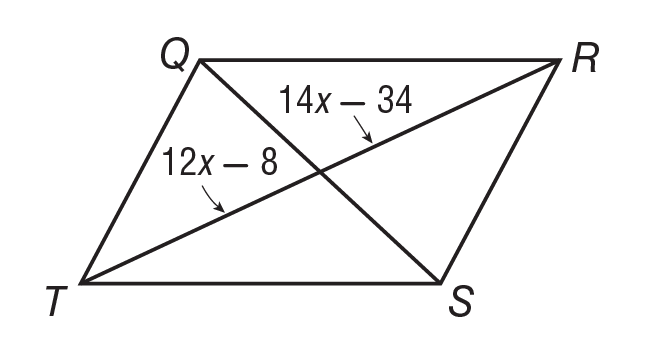Answer the mathemtical geometry problem and directly provide the correct option letter.
Question: If Q R S T is a parallelogram, what is the value of x?
Choices: A: 11 B: 12 C: 13 D: 14 C 